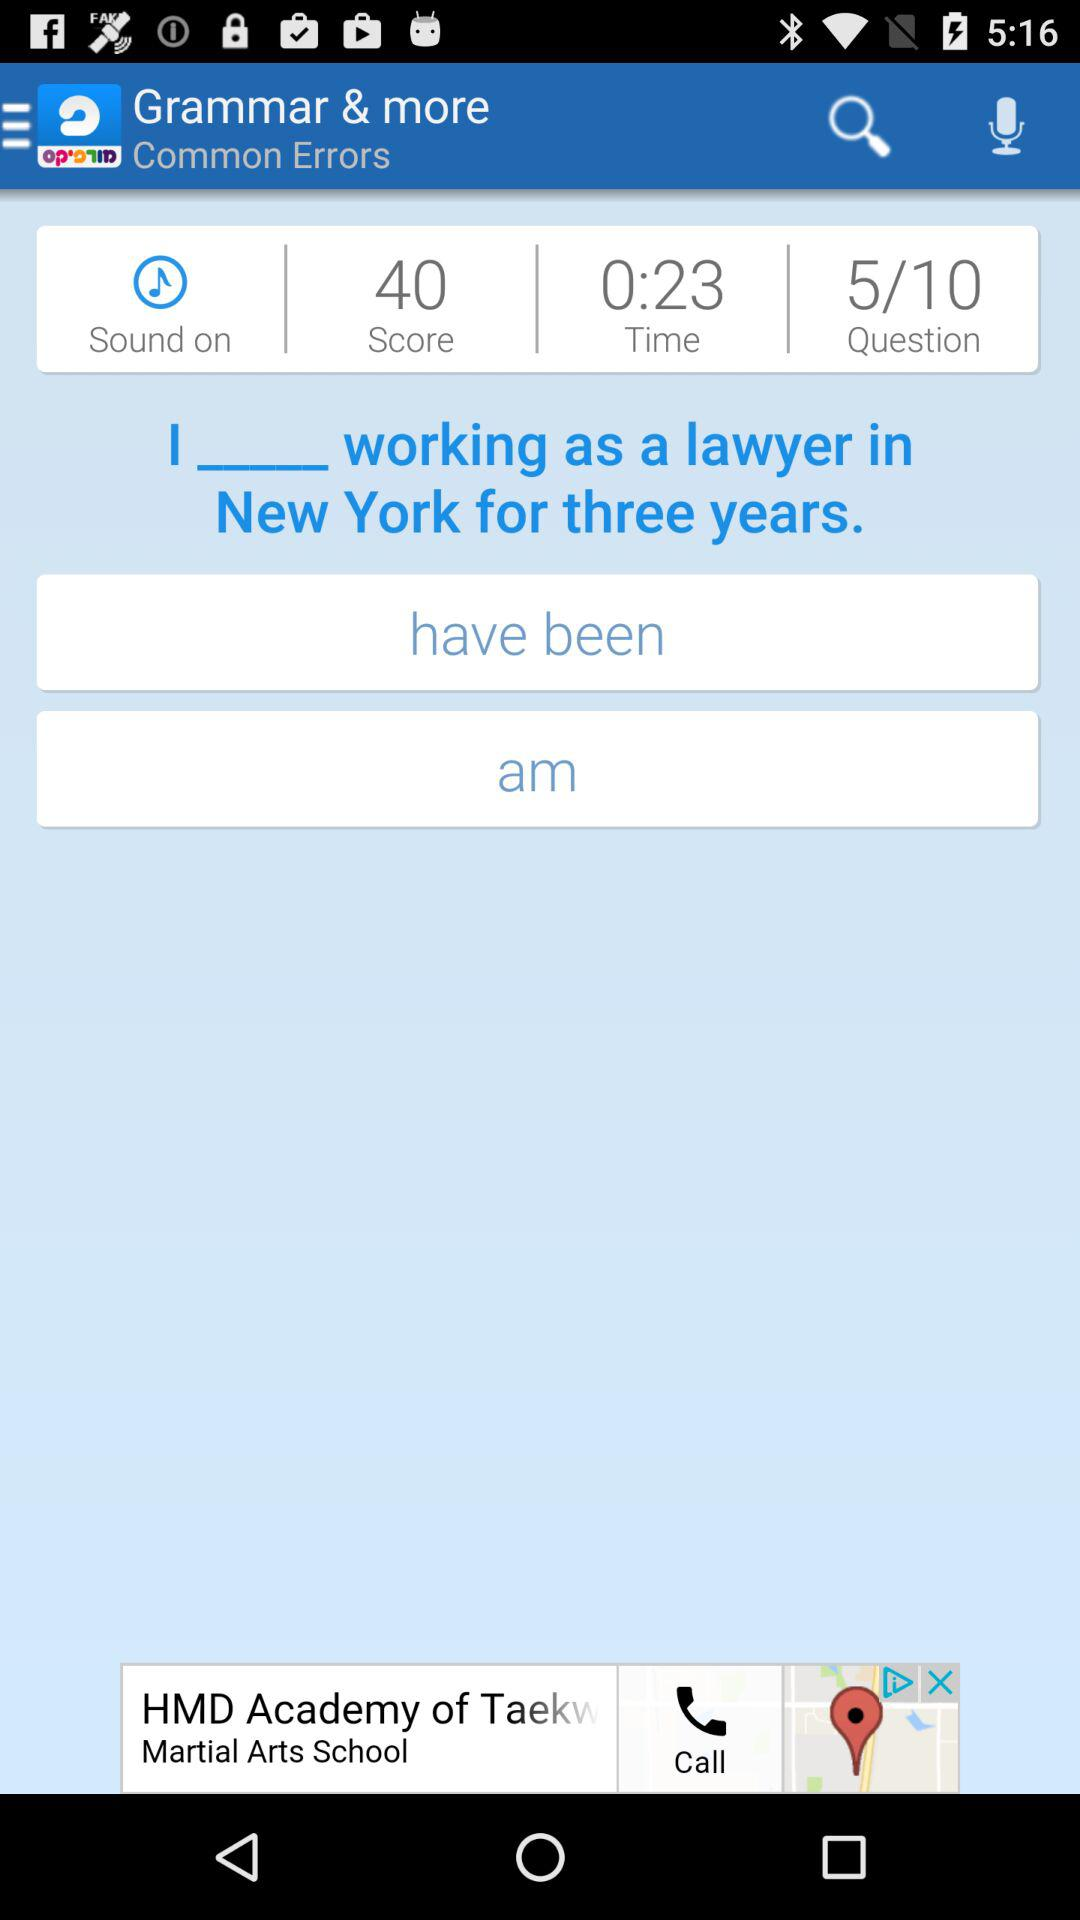Is the sound setting on?
When the provided information is insufficient, respond with <no answer>. <no answer> 